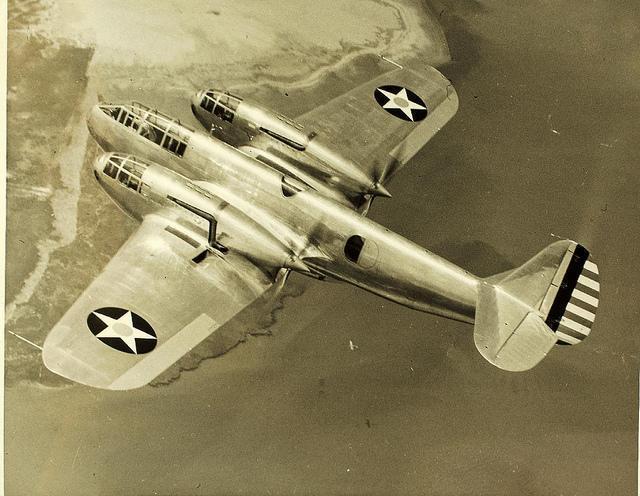How many people are sitting?
Give a very brief answer. 0. 